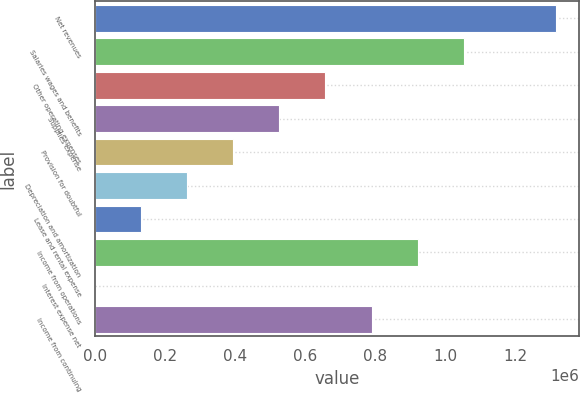<chart> <loc_0><loc_0><loc_500><loc_500><bar_chart><fcel>Net revenues<fcel>Salaries wages and benefits<fcel>Other operating expenses<fcel>Supplies expense<fcel>Provision for doubtful<fcel>Depreciation and amortization<fcel>Lease and rental expense<fcel>Income from operations<fcel>Interest expense net<fcel>Income from continuing<nl><fcel>1.31503e+06<fcel>1.05206e+06<fcel>657619<fcel>526137<fcel>394655<fcel>263173<fcel>131691<fcel>920583<fcel>209<fcel>789101<nl></chart> 